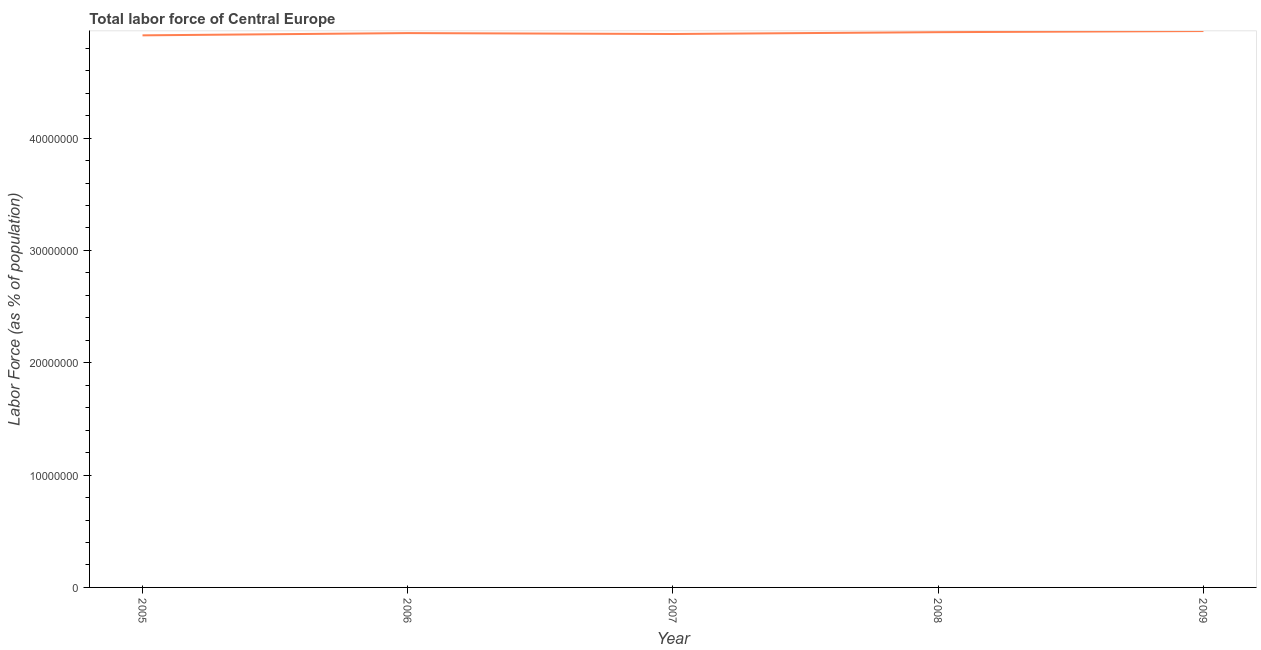What is the total labor force in 2007?
Your answer should be compact. 4.93e+07. Across all years, what is the maximum total labor force?
Offer a very short reply. 4.95e+07. Across all years, what is the minimum total labor force?
Give a very brief answer. 4.91e+07. In which year was the total labor force minimum?
Provide a succinct answer. 2005. What is the sum of the total labor force?
Give a very brief answer. 2.47e+08. What is the difference between the total labor force in 2005 and 2006?
Offer a very short reply. -2.00e+05. What is the average total labor force per year?
Ensure brevity in your answer.  4.93e+07. What is the median total labor force?
Give a very brief answer. 4.93e+07. What is the ratio of the total labor force in 2006 to that in 2009?
Your answer should be very brief. 1. What is the difference between the highest and the second highest total labor force?
Ensure brevity in your answer.  1.00e+05. What is the difference between the highest and the lowest total labor force?
Offer a terse response. 3.83e+05. In how many years, is the total labor force greater than the average total labor force taken over all years?
Keep it short and to the point. 3. Does the total labor force monotonically increase over the years?
Ensure brevity in your answer.  No. How many years are there in the graph?
Ensure brevity in your answer.  5. What is the difference between two consecutive major ticks on the Y-axis?
Offer a very short reply. 1.00e+07. Are the values on the major ticks of Y-axis written in scientific E-notation?
Your answer should be very brief. No. Does the graph contain any zero values?
Make the answer very short. No. What is the title of the graph?
Offer a terse response. Total labor force of Central Europe. What is the label or title of the Y-axis?
Provide a succinct answer. Labor Force (as % of population). What is the Labor Force (as % of population) of 2005?
Your answer should be very brief. 4.91e+07. What is the Labor Force (as % of population) in 2006?
Make the answer very short. 4.93e+07. What is the Labor Force (as % of population) in 2007?
Keep it short and to the point. 4.93e+07. What is the Labor Force (as % of population) in 2008?
Keep it short and to the point. 4.94e+07. What is the Labor Force (as % of population) of 2009?
Give a very brief answer. 4.95e+07. What is the difference between the Labor Force (as % of population) in 2005 and 2006?
Provide a succinct answer. -2.00e+05. What is the difference between the Labor Force (as % of population) in 2005 and 2007?
Make the answer very short. -1.20e+05. What is the difference between the Labor Force (as % of population) in 2005 and 2008?
Your response must be concise. -2.83e+05. What is the difference between the Labor Force (as % of population) in 2005 and 2009?
Your answer should be compact. -3.83e+05. What is the difference between the Labor Force (as % of population) in 2006 and 2007?
Make the answer very short. 8.03e+04. What is the difference between the Labor Force (as % of population) in 2006 and 2008?
Give a very brief answer. -8.30e+04. What is the difference between the Labor Force (as % of population) in 2006 and 2009?
Give a very brief answer. -1.83e+05. What is the difference between the Labor Force (as % of population) in 2007 and 2008?
Provide a succinct answer. -1.63e+05. What is the difference between the Labor Force (as % of population) in 2007 and 2009?
Keep it short and to the point. -2.64e+05. What is the difference between the Labor Force (as % of population) in 2008 and 2009?
Make the answer very short. -1.00e+05. What is the ratio of the Labor Force (as % of population) in 2005 to that in 2006?
Give a very brief answer. 1. What is the ratio of the Labor Force (as % of population) in 2005 to that in 2007?
Your response must be concise. 1. What is the ratio of the Labor Force (as % of population) in 2005 to that in 2009?
Provide a short and direct response. 0.99. What is the ratio of the Labor Force (as % of population) in 2006 to that in 2007?
Provide a short and direct response. 1. What is the ratio of the Labor Force (as % of population) in 2006 to that in 2008?
Ensure brevity in your answer.  1. What is the ratio of the Labor Force (as % of population) in 2007 to that in 2008?
Give a very brief answer. 1. 